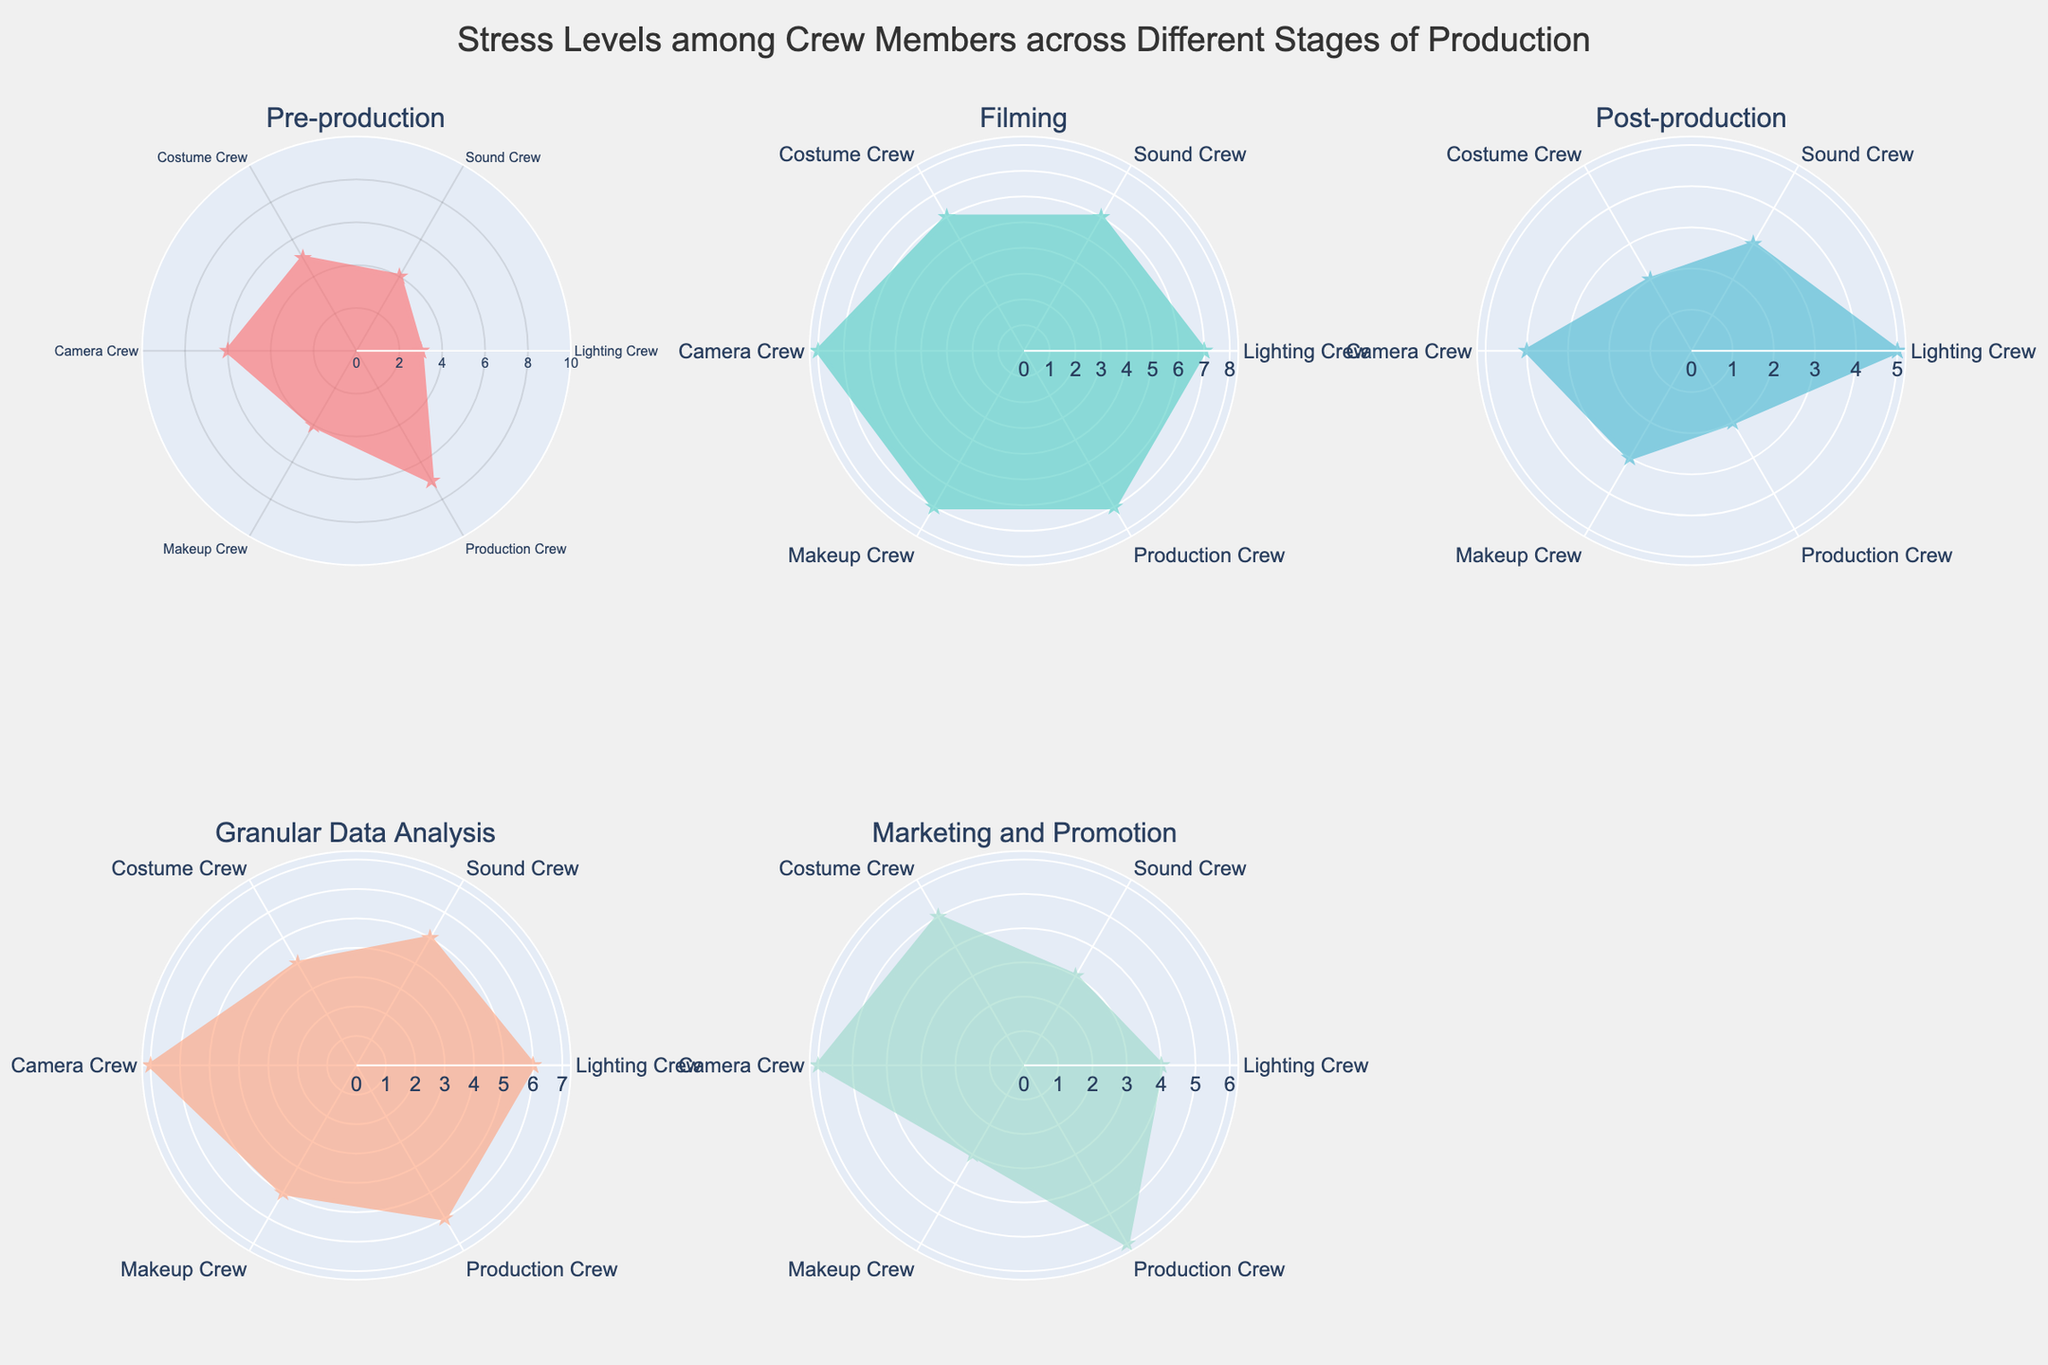What's the title of the figure? The title of the figure is located at the top center of the diagram and provides an overview of what the chart represents. Reading the title directly from the figure gives a clear understanding of its content.
Answer: Stress Levels among Crew Members across Different Stages of Production Which crew member experiences the highest stress level during filming? To determine this, locate the subplot for "Filming" and identify the highest value on the radar chart. This value corresponds to one of the crew members. The Camera Crew shows the highest stress level during filming.
Answer: Camera Crew What is the average stress level of the Production Crew across all stages? Locate the Production Crew values in each subplot, sum them up (7+7+2+6+6), and divide by the number of stages (5). (7+7+2+6+6)/5 = 28/5 = 5.6
Answer: 5.6 Which crew has the most variation in stress levels across all stages? Calculate the range (maximum value - minimum value) for each crew across all stages. The Sound Crew has values of [4, 6, 3, 5, 3] with a range of 6-3=3, which is the highest variation among the crews.
Answer: Sound Crew During which stage does the Costume Crew experience its lowest stress level? Locate the lowest value in the Costume Crew's data across all the subplots. The lowest value for the Costume Crew is 2, found in the Post-production stage.
Answer: Post-production How does the Makeup Crew’s stress level during Granular Data Analysis compare to its stress level during Marketing and Promotion? Identify the stress levels of the Makeup Crew during these two stages on the respective subplots. Granular Data Analysis has a value of 5, and Marketing and Promotion has a value of 3. 5 is greater than 3.
Answer: Higher during Granular Data Analysis Rank stages by average stress levels of all crew members. Calculate the average stress level for each stage by summing the values and dividing by the number of crew members (6). Pre-production: (3+4+5+6+4+7) = 29/6 ≈ 4.8, Filming: (7+6+6+8+7+7) = 41/6 ≈ 6.8, Post-production: (5+3+2+4+3+2) = 19/6 ≈ 3.2, Granular Data Analysis: (6+5+4+7+5+6) = 33/6 ≈ 5.5, Marketing and Promotion: (4+3+5+6+3+6) = 27/6 = 4.5. The ranking is Filming > Granular Data Analysis > Pre-production > Marketing and Promotion > Post-production.
Answer: Filming > Granular Data Analysis > Pre-production > Marketing and Promotion > Post-production Which crew member shows the least stress during Post-production? Find the lowest value in the Post-production subplot. The Costume Crew shows the lowest stress level with a value of 2.
Answer: Costume Crew How much does the Lighting Crew's stress level increase from Pre-production to Filming? Find the values for the Lighting Crew at Pre-production (3) and Filming (7), then subtract the former from the latter. 7 - 3 = 4
Answer: 4 